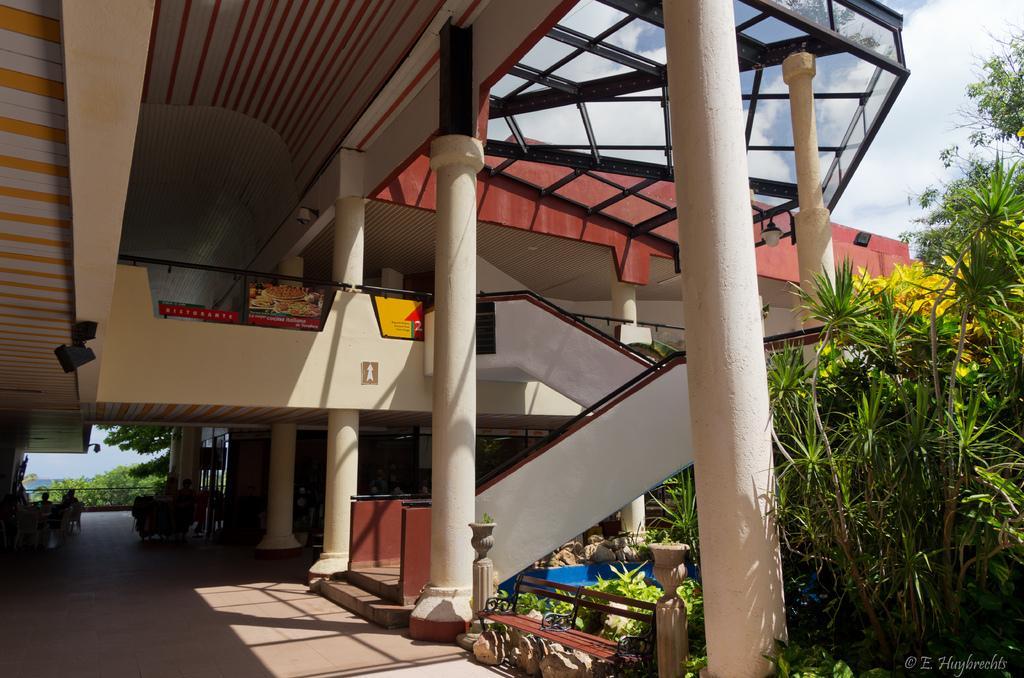Please provide a concise description of this image. In this image we can see a building with pillars and a staircase. We can also see a group of people sitting under a roof, some plants, a fence, some stones, a bench, trees and the sky which looks cloudy. 